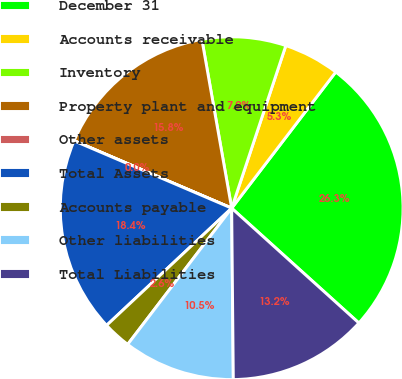Convert chart to OTSL. <chart><loc_0><loc_0><loc_500><loc_500><pie_chart><fcel>December 31<fcel>Accounts receivable<fcel>Inventory<fcel>Property plant and equipment<fcel>Other assets<fcel>Total Assets<fcel>Accounts payable<fcel>Other liabilities<fcel>Total Liabilities<nl><fcel>26.3%<fcel>5.27%<fcel>7.9%<fcel>15.78%<fcel>0.01%<fcel>18.41%<fcel>2.64%<fcel>10.53%<fcel>13.16%<nl></chart> 